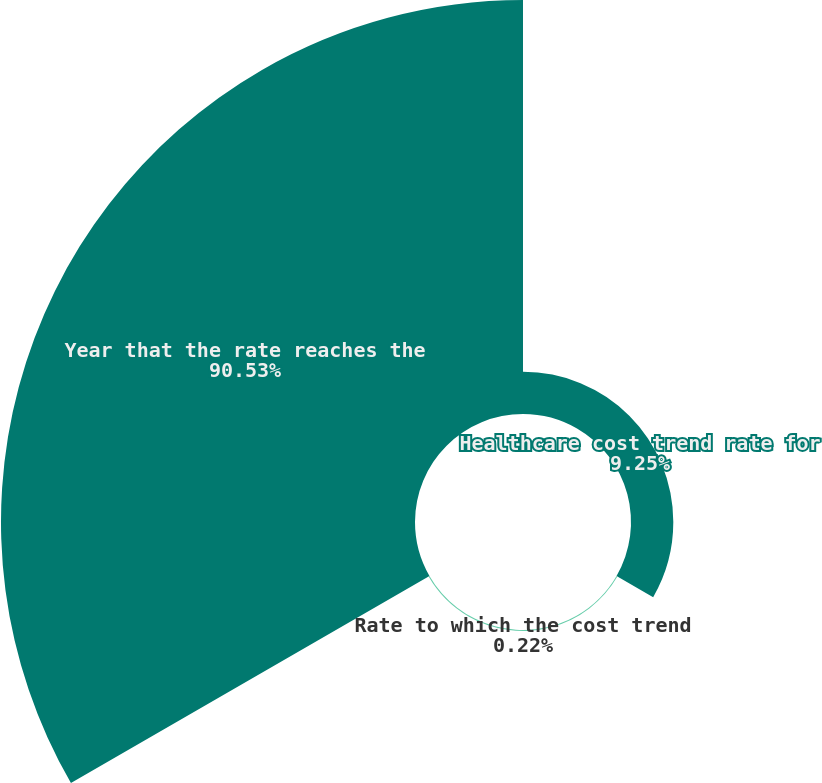<chart> <loc_0><loc_0><loc_500><loc_500><pie_chart><fcel>Healthcare cost trend rate for<fcel>Rate to which the cost trend<fcel>Year that the rate reaches the<nl><fcel>9.25%<fcel>0.22%<fcel>90.52%<nl></chart> 